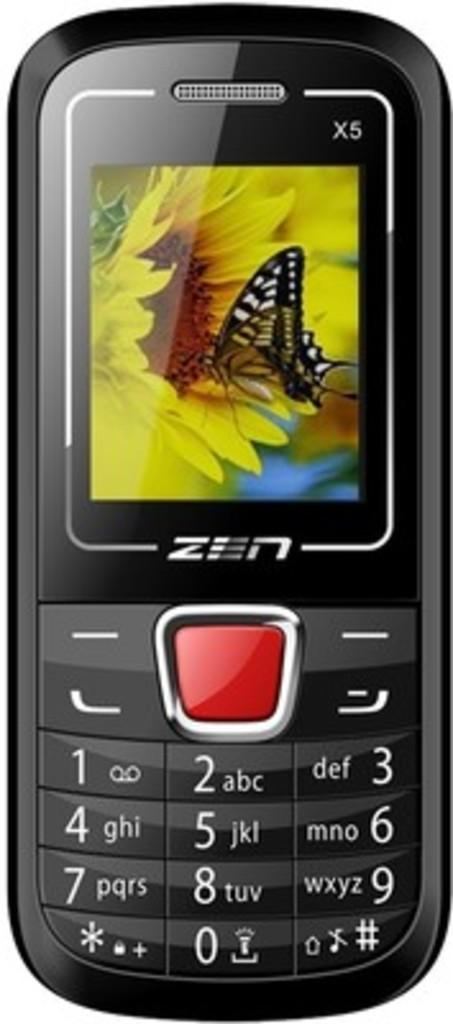<image>
Relay a brief, clear account of the picture shown. a ZEN phone shows a yellow sunflower and buttefly on the screen 